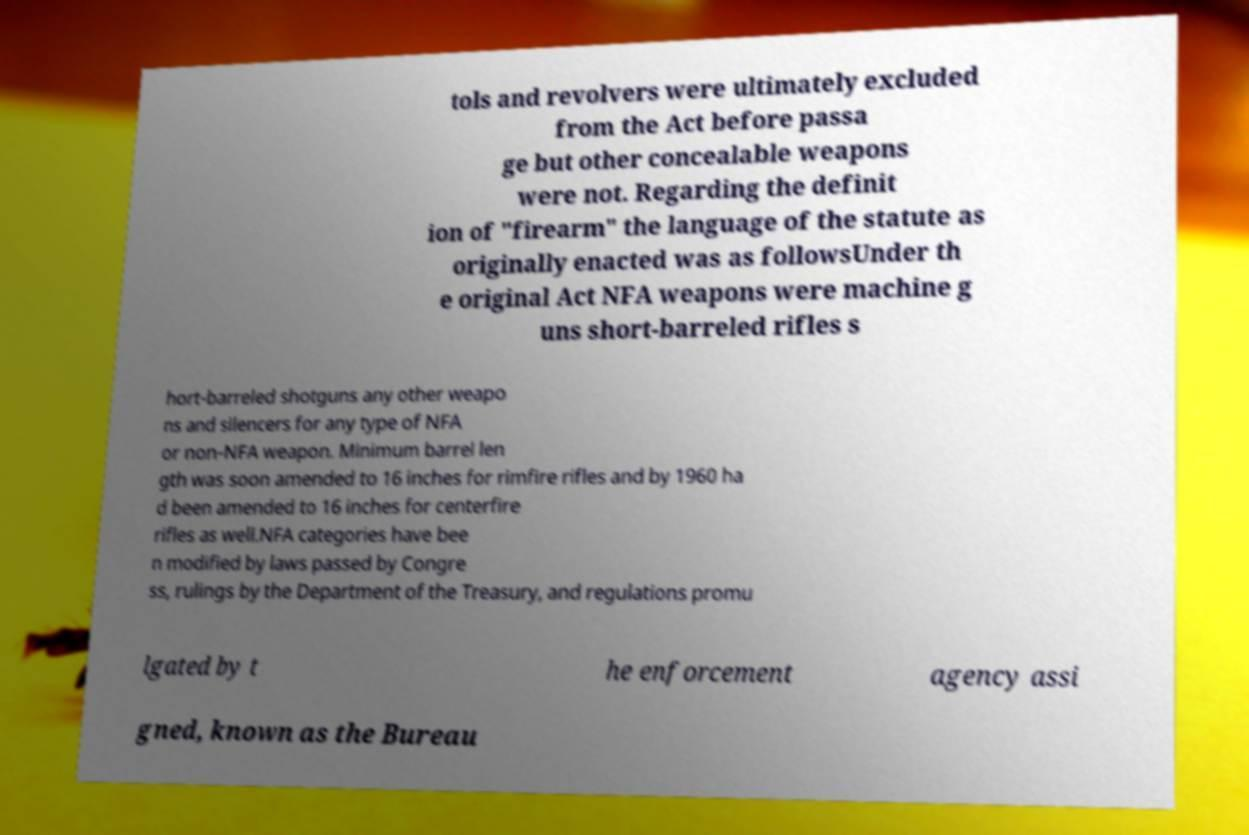Could you extract and type out the text from this image? tols and revolvers were ultimately excluded from the Act before passa ge but other concealable weapons were not. Regarding the definit ion of "firearm" the language of the statute as originally enacted was as followsUnder th e original Act NFA weapons were machine g uns short-barreled rifles s hort-barreled shotguns any other weapo ns and silencers for any type of NFA or non-NFA weapon. Minimum barrel len gth was soon amended to 16 inches for rimfire rifles and by 1960 ha d been amended to 16 inches for centerfire rifles as well.NFA categories have bee n modified by laws passed by Congre ss, rulings by the Department of the Treasury, and regulations promu lgated by t he enforcement agency assi gned, known as the Bureau 